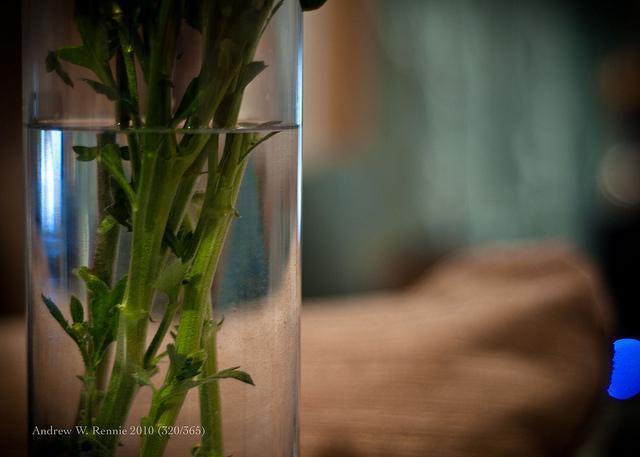How many bases are on the shelf?
Give a very brief answer. 1. How many limbs are shown?
Give a very brief answer. 0. How many flowers are in the vase?
Give a very brief answer. 4. How many pizzas are on the table?
Give a very brief answer. 0. 